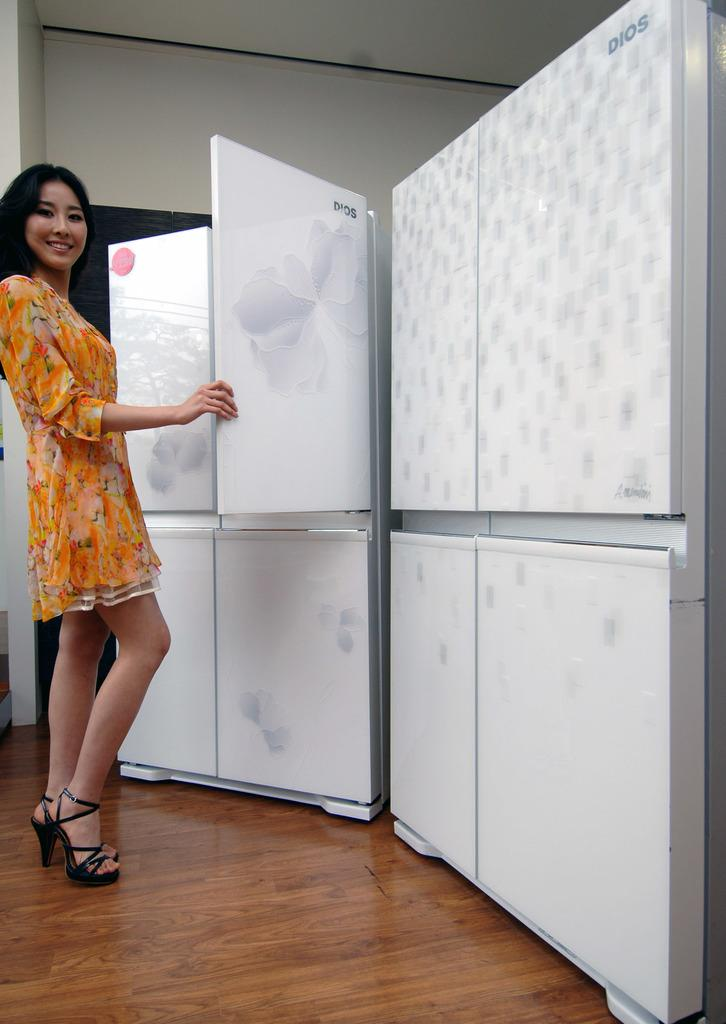<image>
Present a compact description of the photo's key features. A woman in a flowered dress holds open the door of a DIOS refrigerator. 